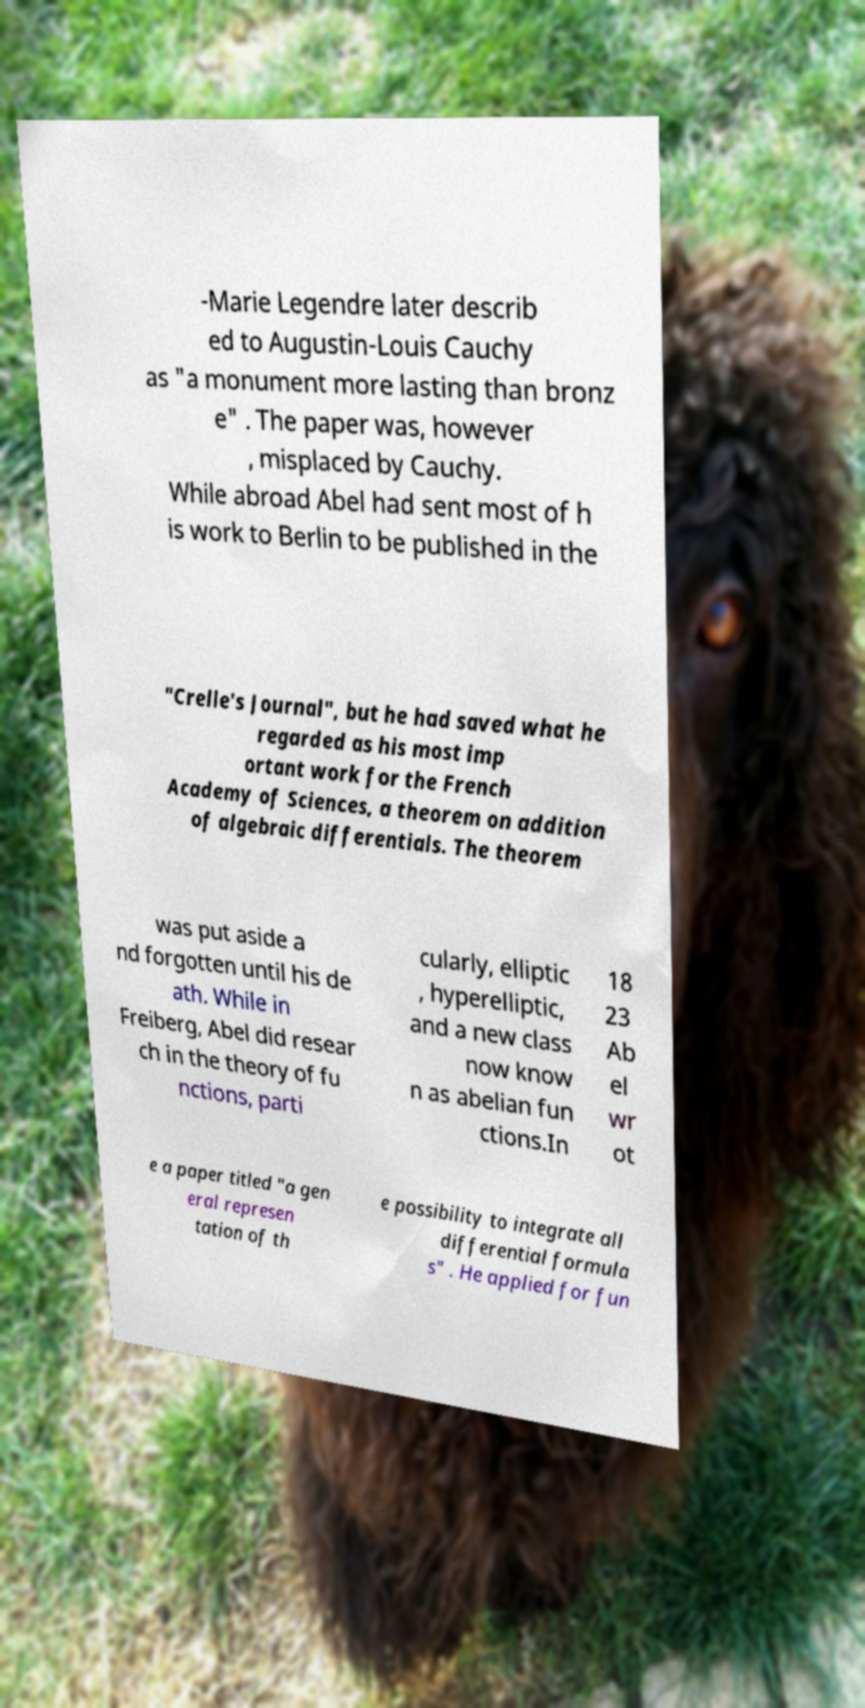For documentation purposes, I need the text within this image transcribed. Could you provide that? -Marie Legendre later describ ed to Augustin-Louis Cauchy as "a monument more lasting than bronz e" . The paper was, however , misplaced by Cauchy. While abroad Abel had sent most of h is work to Berlin to be published in the "Crelle's Journal", but he had saved what he regarded as his most imp ortant work for the French Academy of Sciences, a theorem on addition of algebraic differentials. The theorem was put aside a nd forgotten until his de ath. While in Freiberg, Abel did resear ch in the theory of fu nctions, parti cularly, elliptic , hyperelliptic, and a new class now know n as abelian fun ctions.In 18 23 Ab el wr ot e a paper titled "a gen eral represen tation of th e possibility to integrate all differential formula s" . He applied for fun 